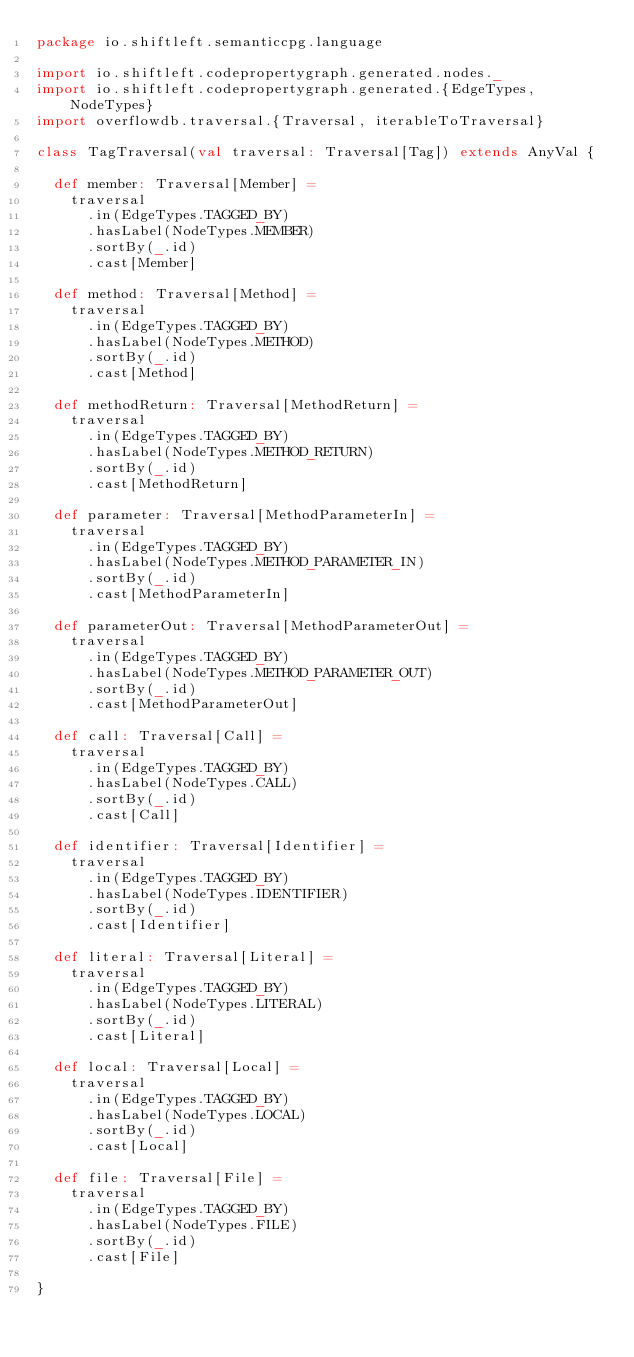Convert code to text. <code><loc_0><loc_0><loc_500><loc_500><_Scala_>package io.shiftleft.semanticcpg.language

import io.shiftleft.codepropertygraph.generated.nodes._
import io.shiftleft.codepropertygraph.generated.{EdgeTypes, NodeTypes}
import overflowdb.traversal.{Traversal, iterableToTraversal}

class TagTraversal(val traversal: Traversal[Tag]) extends AnyVal {

  def member: Traversal[Member] =
    traversal
      .in(EdgeTypes.TAGGED_BY)
      .hasLabel(NodeTypes.MEMBER)
      .sortBy(_.id)
      .cast[Member]

  def method: Traversal[Method] =
    traversal
      .in(EdgeTypes.TAGGED_BY)
      .hasLabel(NodeTypes.METHOD)
      .sortBy(_.id)
      .cast[Method]

  def methodReturn: Traversal[MethodReturn] =
    traversal
      .in(EdgeTypes.TAGGED_BY)
      .hasLabel(NodeTypes.METHOD_RETURN)
      .sortBy(_.id)
      .cast[MethodReturn]

  def parameter: Traversal[MethodParameterIn] =
    traversal
      .in(EdgeTypes.TAGGED_BY)
      .hasLabel(NodeTypes.METHOD_PARAMETER_IN)
      .sortBy(_.id)
      .cast[MethodParameterIn]

  def parameterOut: Traversal[MethodParameterOut] =
    traversal
      .in(EdgeTypes.TAGGED_BY)
      .hasLabel(NodeTypes.METHOD_PARAMETER_OUT)
      .sortBy(_.id)
      .cast[MethodParameterOut]

  def call: Traversal[Call] =
    traversal
      .in(EdgeTypes.TAGGED_BY)
      .hasLabel(NodeTypes.CALL)
      .sortBy(_.id)
      .cast[Call]

  def identifier: Traversal[Identifier] =
    traversal
      .in(EdgeTypes.TAGGED_BY)
      .hasLabel(NodeTypes.IDENTIFIER)
      .sortBy(_.id)
      .cast[Identifier]

  def literal: Traversal[Literal] =
    traversal
      .in(EdgeTypes.TAGGED_BY)
      .hasLabel(NodeTypes.LITERAL)
      .sortBy(_.id)
      .cast[Literal]

  def local: Traversal[Local] =
    traversal
      .in(EdgeTypes.TAGGED_BY)
      .hasLabel(NodeTypes.LOCAL)
      .sortBy(_.id)
      .cast[Local]

  def file: Traversal[File] =
    traversal
      .in(EdgeTypes.TAGGED_BY)
      .hasLabel(NodeTypes.FILE)
      .sortBy(_.id)
      .cast[File]

}
</code> 